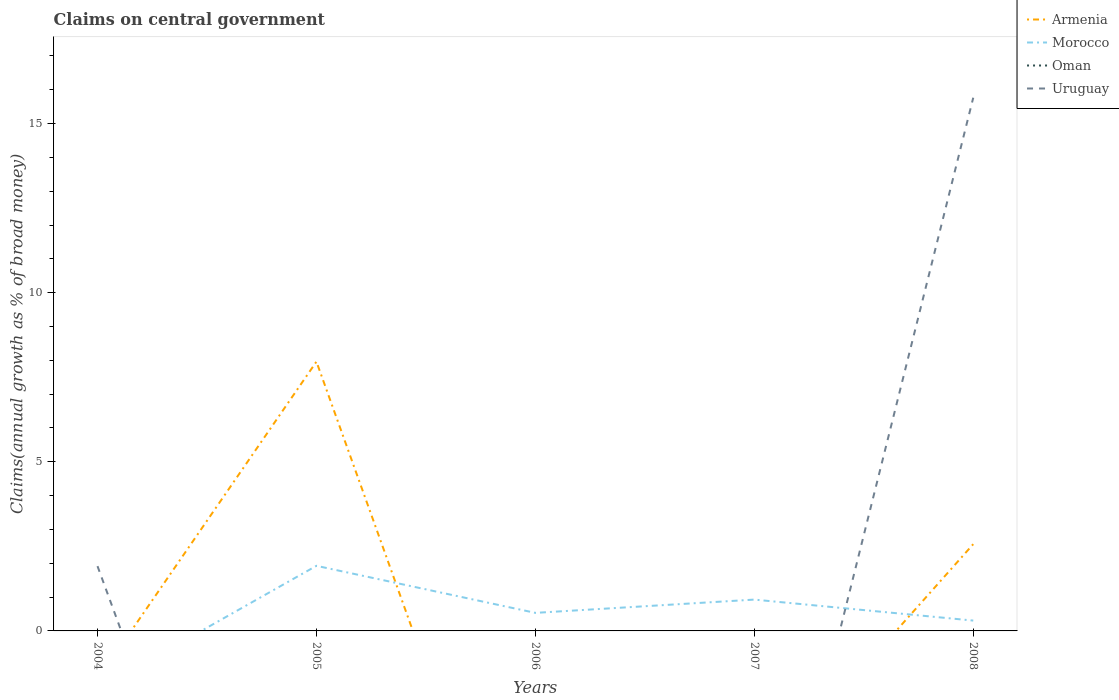How many different coloured lines are there?
Your answer should be compact. 3. Does the line corresponding to Oman intersect with the line corresponding to Morocco?
Offer a very short reply. No. Is the number of lines equal to the number of legend labels?
Provide a succinct answer. No. Across all years, what is the maximum percentage of broad money claimed on centeral government in Oman?
Make the answer very short. 0. What is the total percentage of broad money claimed on centeral government in Morocco in the graph?
Offer a very short reply. 1.39. What is the difference between the highest and the second highest percentage of broad money claimed on centeral government in Uruguay?
Your answer should be very brief. 15.77. How many lines are there?
Offer a very short reply. 3. How many years are there in the graph?
Your response must be concise. 5. What is the difference between two consecutive major ticks on the Y-axis?
Provide a succinct answer. 5. Are the values on the major ticks of Y-axis written in scientific E-notation?
Offer a very short reply. No. Does the graph contain grids?
Keep it short and to the point. No. Where does the legend appear in the graph?
Give a very brief answer. Top right. What is the title of the graph?
Your answer should be very brief. Claims on central government. What is the label or title of the Y-axis?
Offer a very short reply. Claims(annual growth as % of broad money). What is the Claims(annual growth as % of broad money) in Uruguay in 2004?
Provide a succinct answer. 1.92. What is the Claims(annual growth as % of broad money) in Armenia in 2005?
Your answer should be compact. 7.96. What is the Claims(annual growth as % of broad money) of Morocco in 2005?
Provide a short and direct response. 1.92. What is the Claims(annual growth as % of broad money) of Uruguay in 2005?
Ensure brevity in your answer.  0. What is the Claims(annual growth as % of broad money) of Morocco in 2006?
Your response must be concise. 0.53. What is the Claims(annual growth as % of broad money) in Oman in 2006?
Offer a terse response. 0. What is the Claims(annual growth as % of broad money) in Armenia in 2007?
Provide a succinct answer. 0. What is the Claims(annual growth as % of broad money) in Morocco in 2007?
Your answer should be very brief. 0.93. What is the Claims(annual growth as % of broad money) in Uruguay in 2007?
Your answer should be very brief. 0. What is the Claims(annual growth as % of broad money) in Armenia in 2008?
Offer a very short reply. 2.57. What is the Claims(annual growth as % of broad money) in Morocco in 2008?
Make the answer very short. 0.31. What is the Claims(annual growth as % of broad money) of Oman in 2008?
Your answer should be very brief. 0. What is the Claims(annual growth as % of broad money) of Uruguay in 2008?
Offer a very short reply. 15.77. Across all years, what is the maximum Claims(annual growth as % of broad money) of Armenia?
Your response must be concise. 7.96. Across all years, what is the maximum Claims(annual growth as % of broad money) in Morocco?
Your answer should be very brief. 1.92. Across all years, what is the maximum Claims(annual growth as % of broad money) in Uruguay?
Ensure brevity in your answer.  15.77. Across all years, what is the minimum Claims(annual growth as % of broad money) of Armenia?
Your response must be concise. 0. What is the total Claims(annual growth as % of broad money) of Armenia in the graph?
Make the answer very short. 10.53. What is the total Claims(annual growth as % of broad money) in Morocco in the graph?
Make the answer very short. 3.69. What is the total Claims(annual growth as % of broad money) of Oman in the graph?
Your answer should be very brief. 0. What is the total Claims(annual growth as % of broad money) of Uruguay in the graph?
Your answer should be very brief. 17.68. What is the difference between the Claims(annual growth as % of broad money) of Uruguay in 2004 and that in 2008?
Keep it short and to the point. -13.85. What is the difference between the Claims(annual growth as % of broad money) in Morocco in 2005 and that in 2006?
Your response must be concise. 1.39. What is the difference between the Claims(annual growth as % of broad money) in Armenia in 2005 and that in 2008?
Keep it short and to the point. 5.4. What is the difference between the Claims(annual growth as % of broad money) of Morocco in 2005 and that in 2008?
Your answer should be very brief. 1.62. What is the difference between the Claims(annual growth as % of broad money) in Morocco in 2006 and that in 2007?
Your answer should be very brief. -0.39. What is the difference between the Claims(annual growth as % of broad money) in Morocco in 2006 and that in 2008?
Offer a terse response. 0.23. What is the difference between the Claims(annual growth as % of broad money) of Morocco in 2007 and that in 2008?
Provide a short and direct response. 0.62. What is the difference between the Claims(annual growth as % of broad money) of Armenia in 2005 and the Claims(annual growth as % of broad money) of Morocco in 2006?
Keep it short and to the point. 7.43. What is the difference between the Claims(annual growth as % of broad money) of Armenia in 2005 and the Claims(annual growth as % of broad money) of Morocco in 2007?
Provide a succinct answer. 7.04. What is the difference between the Claims(annual growth as % of broad money) in Armenia in 2005 and the Claims(annual growth as % of broad money) in Morocco in 2008?
Your answer should be compact. 7.66. What is the difference between the Claims(annual growth as % of broad money) in Armenia in 2005 and the Claims(annual growth as % of broad money) in Uruguay in 2008?
Your answer should be compact. -7.8. What is the difference between the Claims(annual growth as % of broad money) of Morocco in 2005 and the Claims(annual growth as % of broad money) of Uruguay in 2008?
Your answer should be compact. -13.84. What is the difference between the Claims(annual growth as % of broad money) in Morocco in 2006 and the Claims(annual growth as % of broad money) in Uruguay in 2008?
Keep it short and to the point. -15.23. What is the difference between the Claims(annual growth as % of broad money) of Morocco in 2007 and the Claims(annual growth as % of broad money) of Uruguay in 2008?
Ensure brevity in your answer.  -14.84. What is the average Claims(annual growth as % of broad money) in Armenia per year?
Your response must be concise. 2.11. What is the average Claims(annual growth as % of broad money) in Morocco per year?
Your answer should be compact. 0.74. What is the average Claims(annual growth as % of broad money) in Uruguay per year?
Provide a short and direct response. 3.54. In the year 2005, what is the difference between the Claims(annual growth as % of broad money) of Armenia and Claims(annual growth as % of broad money) of Morocco?
Make the answer very short. 6.04. In the year 2008, what is the difference between the Claims(annual growth as % of broad money) in Armenia and Claims(annual growth as % of broad money) in Morocco?
Offer a very short reply. 2.26. In the year 2008, what is the difference between the Claims(annual growth as % of broad money) of Armenia and Claims(annual growth as % of broad money) of Uruguay?
Your answer should be compact. -13.2. In the year 2008, what is the difference between the Claims(annual growth as % of broad money) of Morocco and Claims(annual growth as % of broad money) of Uruguay?
Ensure brevity in your answer.  -15.46. What is the ratio of the Claims(annual growth as % of broad money) in Uruguay in 2004 to that in 2008?
Keep it short and to the point. 0.12. What is the ratio of the Claims(annual growth as % of broad money) in Morocco in 2005 to that in 2006?
Offer a terse response. 3.61. What is the ratio of the Claims(annual growth as % of broad money) in Morocco in 2005 to that in 2007?
Provide a succinct answer. 2.08. What is the ratio of the Claims(annual growth as % of broad money) of Armenia in 2005 to that in 2008?
Give a very brief answer. 3.1. What is the ratio of the Claims(annual growth as % of broad money) in Morocco in 2005 to that in 2008?
Your response must be concise. 6.29. What is the ratio of the Claims(annual growth as % of broad money) in Morocco in 2006 to that in 2007?
Provide a succinct answer. 0.58. What is the ratio of the Claims(annual growth as % of broad money) of Morocco in 2006 to that in 2008?
Your response must be concise. 1.74. What is the ratio of the Claims(annual growth as % of broad money) of Morocco in 2007 to that in 2008?
Provide a succinct answer. 3.03. What is the difference between the highest and the lowest Claims(annual growth as % of broad money) of Armenia?
Give a very brief answer. 7.96. What is the difference between the highest and the lowest Claims(annual growth as % of broad money) in Morocco?
Offer a very short reply. 1.92. What is the difference between the highest and the lowest Claims(annual growth as % of broad money) in Uruguay?
Give a very brief answer. 15.77. 